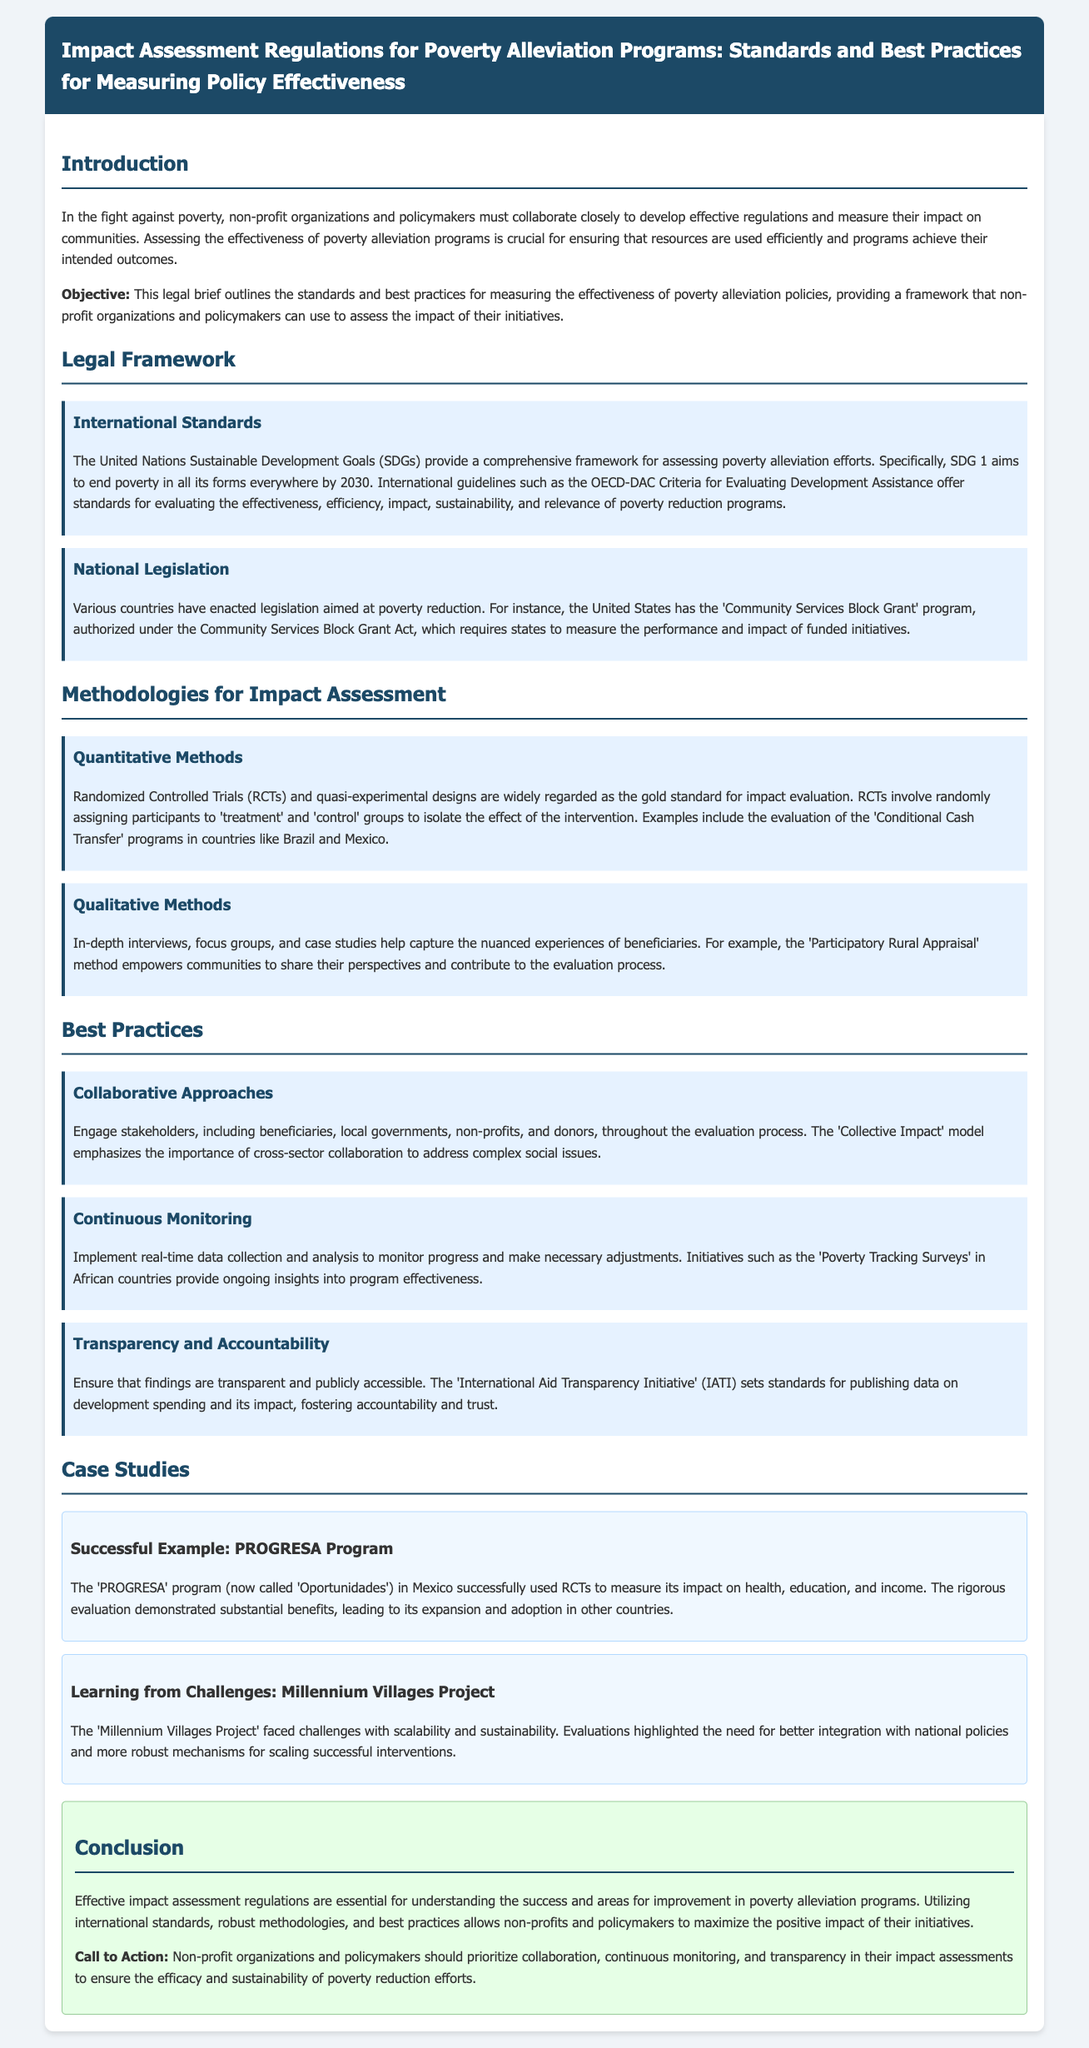What is the primary objective of the legal brief? The objective outlines the standards and best practices for measuring the effectiveness of poverty alleviation policies.
Answer: Standards and best practices for measuring effectiveness What does SDG 1 aim to achieve? SDG 1 specifically aims to end poverty in all its forms everywhere by 2030.
Answer: End poverty in all its forms everywhere by 2030 Which country has the 'Community Services Block Grant' program? The United States has enacted the 'Community Services Block Grant' program.
Answer: United States What are considered the gold standard for impact evaluation? Randomized Controlled Trials (RCTs) and quasi-experimental designs are regarded as the gold standard.
Answer: Randomized Controlled Trials (RCTs) What method empowers communities in the evaluation process? The 'Participatory Rural Appraisal' method empowers communities to share their perspectives.
Answer: Participatory Rural Appraisal What model emphasizes cross-sector collaboration? The 'Collective Impact' model emphasizes the importance of cross-sector collaboration.
Answer: Collective Impact What type of surveys provide ongoing insights into program effectiveness? 'Poverty Tracking Surveys' in African countries provide ongoing insights.
Answer: Poverty Tracking Surveys What was a successful example mentioned in the case studies? The 'PROGRESA' program in Mexico is a successful example of impact measurement.
Answer: PROGRESA Program What challenge did the Millennium Villages Project face? The project faced challenges with scalability and sustainability.
Answer: Scalability and sustainability 